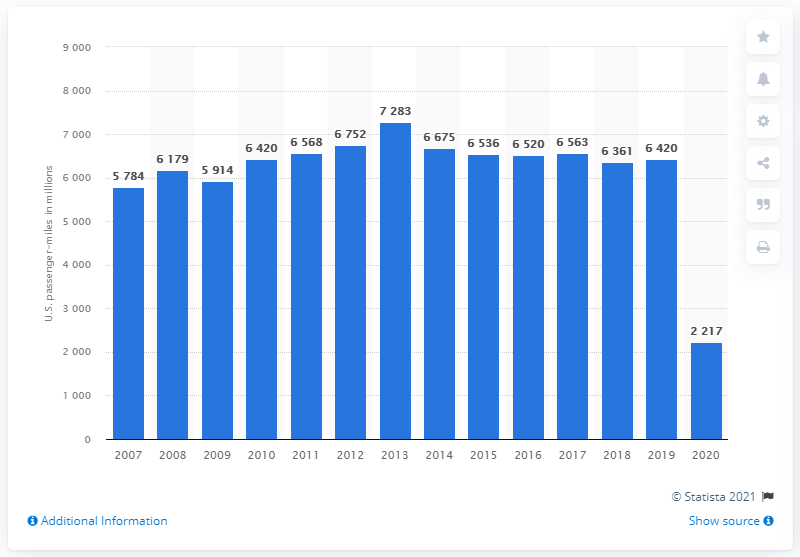Highlight a few significant elements in this photo. In 2020, Intercity/Amtrak passengers traveled a total of 22,170 miles. 